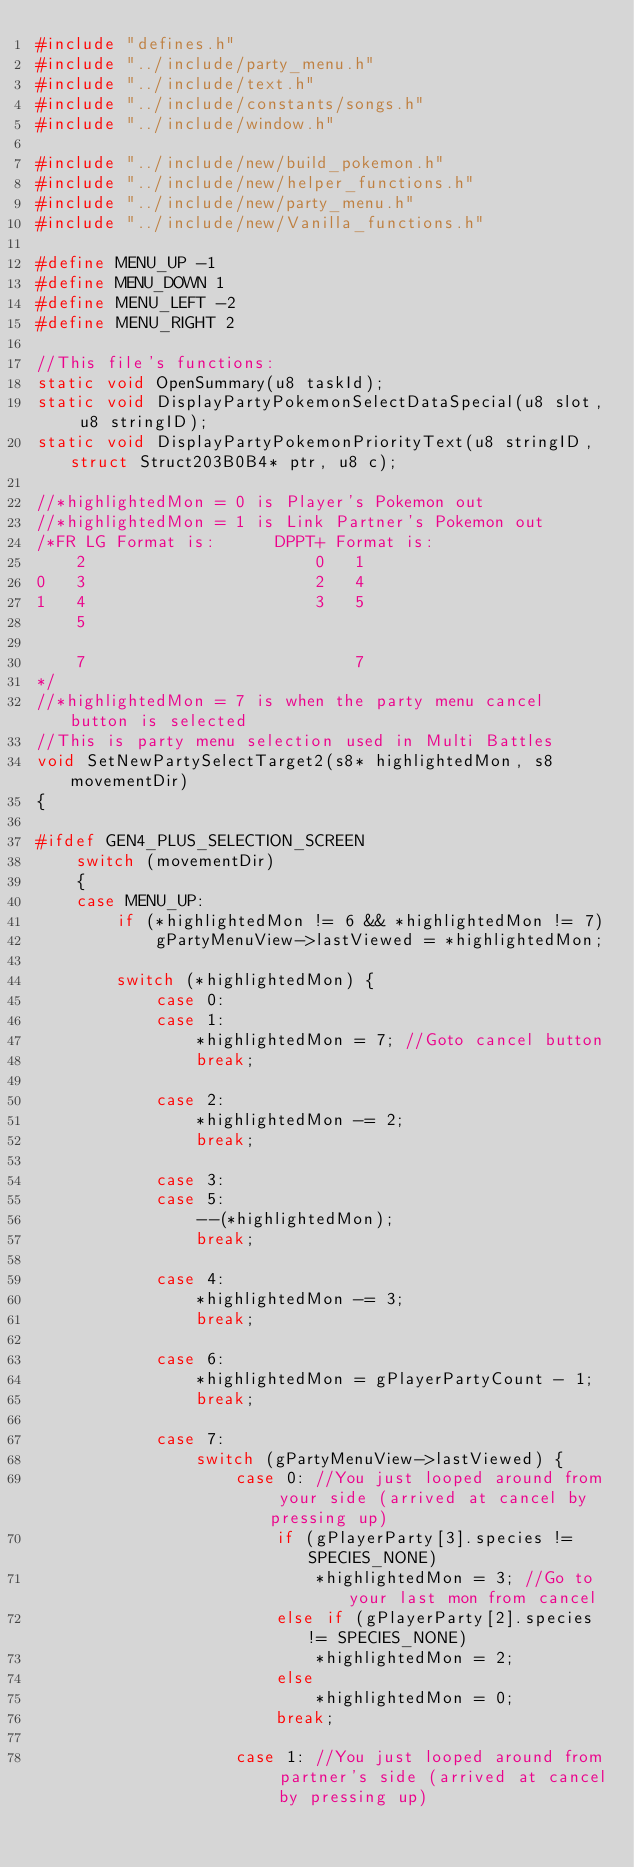Convert code to text. <code><loc_0><loc_0><loc_500><loc_500><_C_>#include "defines.h"
#include "../include/party_menu.h"
#include "../include/text.h"
#include "../include/constants/songs.h"
#include "../include/window.h"

#include "../include/new/build_pokemon.h"
#include "../include/new/helper_functions.h"
#include "../include/new/party_menu.h"
#include "../include/new/Vanilla_functions.h"

#define MENU_UP -1
#define MENU_DOWN 1
#define MENU_LEFT -2
#define MENU_RIGHT 2

//This file's functions:
static void OpenSummary(u8 taskId);
static void DisplayPartyPokemonSelectDataSpecial(u8 slot, u8 stringID);
static void DisplayPartyPokemonPriorityText(u8 stringID, struct Struct203B0B4* ptr, u8 c);

//*highlightedMon = 0 is Player's Pokemon out
//*highlightedMon = 1 is Link Partner's Pokemon out
/*FR LG Format is:		DPPT+ Format is:
	2						0	1
0	3						2	4
1	4						3	5
	5
	
	7							7
*/
//*highlightedMon = 7 is when the party menu cancel button is selected
//This is party menu selection used in Multi Battles
void SetNewPartySelectTarget2(s8* highlightedMon, s8 movementDir)
{
	
#ifdef GEN4_PLUS_SELECTION_SCREEN
    switch (movementDir)
    {
    case MENU_UP:
		if (*highlightedMon != 6 && *highlightedMon != 7)
			gPartyMenuView->lastViewed = *highlightedMon;
			
		switch (*highlightedMon) {
			case 0:
			case 1:
				*highlightedMon = 7; //Goto cancel button
				break;
			
			case 2:
				*highlightedMon -= 2;
				break;
			
			case 3:
			case 5:
				--(*highlightedMon);
				break;
				
			case 4:
				*highlightedMon -= 3;
				break;
			
			case 6:
				*highlightedMon = gPlayerPartyCount - 1;
				break;
			
			case 7:
				switch (gPartyMenuView->lastViewed) {
					case 0: //You just looped around from your side (arrived at cancel by pressing up)
						if (gPlayerParty[3].species != SPECIES_NONE)
							*highlightedMon = 3; //Go to your last mon from cancel
						else if (gPlayerParty[2].species != SPECIES_NONE)
							*highlightedMon = 2;
						else
							*highlightedMon = 0;
						break;
					
					case 1: //You just looped around from partner's side (arrived at cancel by pressing up)</code> 